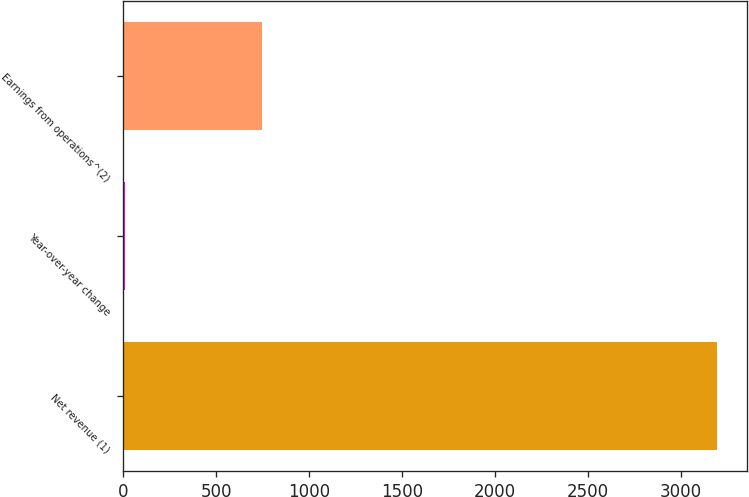Convert chart. <chart><loc_0><loc_0><loc_500><loc_500><bar_chart><fcel>Net revenue (1)<fcel>Year-over-year change<fcel>Earnings from operations^(2)<nl><fcel>3195<fcel>11.8<fcel>749<nl></chart> 